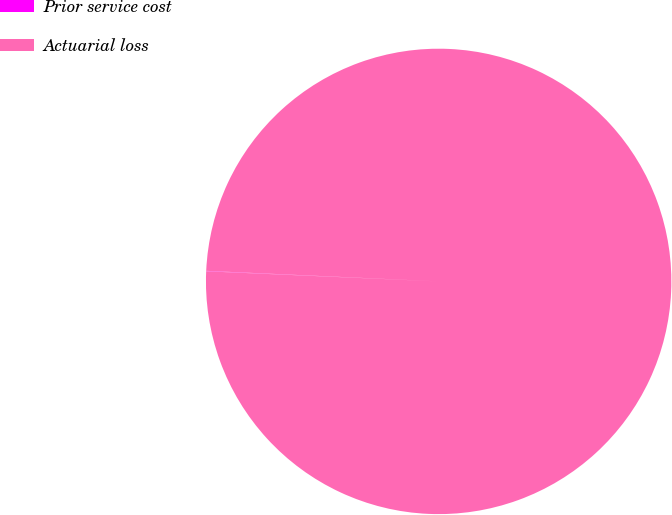Convert chart to OTSL. <chart><loc_0><loc_0><loc_500><loc_500><pie_chart><fcel>Prior service cost<fcel>Actuarial loss<nl><fcel>0.03%<fcel>99.97%<nl></chart> 